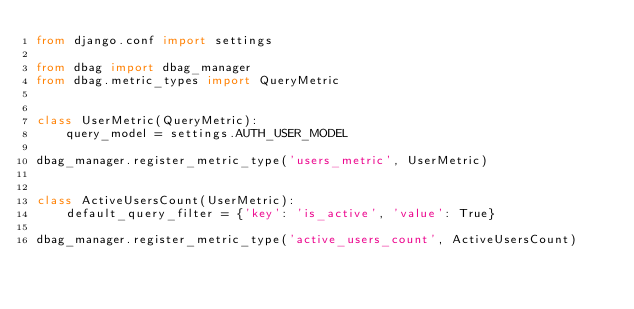Convert code to text. <code><loc_0><loc_0><loc_500><loc_500><_Python_>from django.conf import settings

from dbag import dbag_manager
from dbag.metric_types import QueryMetric


class UserMetric(QueryMetric):
    query_model = settings.AUTH_USER_MODEL

dbag_manager.register_metric_type('users_metric', UserMetric)


class ActiveUsersCount(UserMetric):
    default_query_filter = {'key': 'is_active', 'value': True}

dbag_manager.register_metric_type('active_users_count', ActiveUsersCount)
</code> 